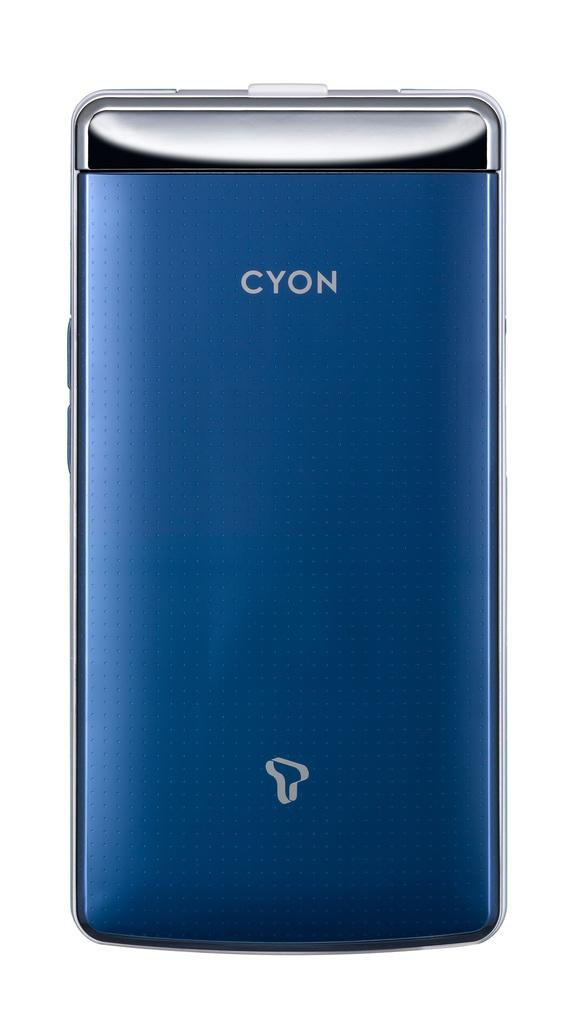<image>
Share a concise interpretation of the image provided. a blue smart phone brand cyon white screen on the back 